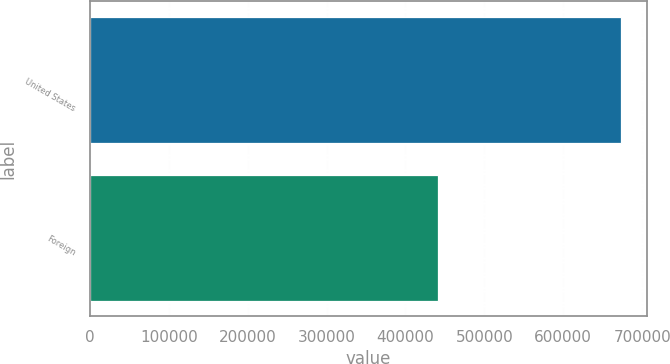Convert chart to OTSL. <chart><loc_0><loc_0><loc_500><loc_500><bar_chart><fcel>United States<fcel>Foreign<nl><fcel>672907<fcel>441821<nl></chart> 